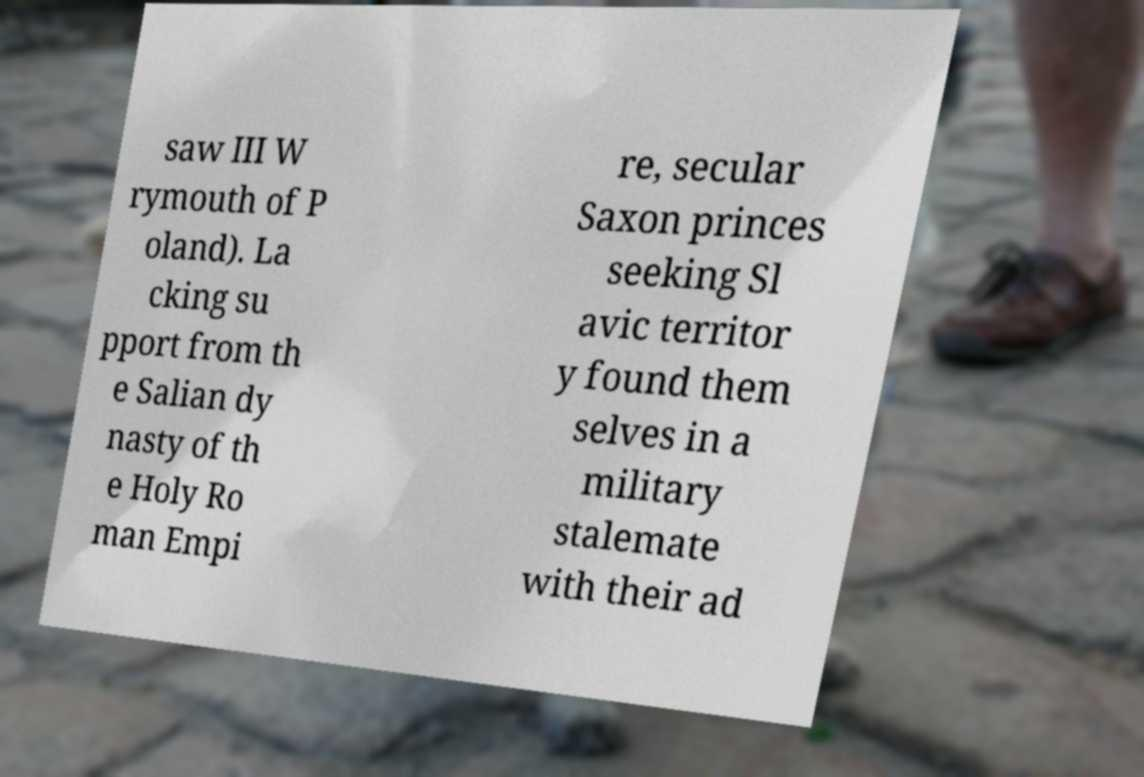Please identify and transcribe the text found in this image. saw III W rymouth of P oland). La cking su pport from th e Salian dy nasty of th e Holy Ro man Empi re, secular Saxon princes seeking Sl avic territor y found them selves in a military stalemate with their ad 